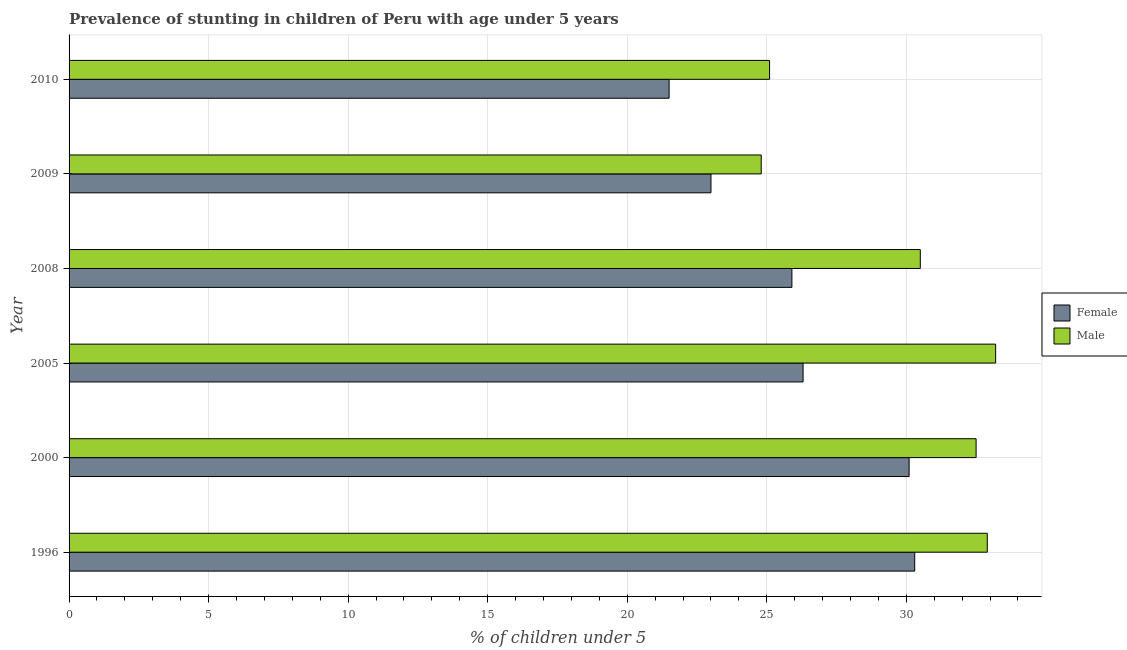How many groups of bars are there?
Keep it short and to the point. 6. Are the number of bars per tick equal to the number of legend labels?
Your response must be concise. Yes. What is the percentage of stunted female children in 2010?
Give a very brief answer. 21.5. Across all years, what is the maximum percentage of stunted female children?
Make the answer very short. 30.3. Across all years, what is the minimum percentage of stunted male children?
Offer a very short reply. 24.8. In which year was the percentage of stunted female children maximum?
Give a very brief answer. 1996. What is the total percentage of stunted female children in the graph?
Make the answer very short. 157.1. What is the difference between the percentage of stunted male children in 2000 and that in 2009?
Make the answer very short. 7.7. What is the difference between the percentage of stunted female children in 2000 and the percentage of stunted male children in 2010?
Your answer should be compact. 5. What is the average percentage of stunted male children per year?
Keep it short and to the point. 29.83. In the year 2005, what is the difference between the percentage of stunted female children and percentage of stunted male children?
Your answer should be very brief. -6.9. In how many years, is the percentage of stunted male children greater than 28 %?
Offer a very short reply. 4. Is the percentage of stunted male children in 2000 less than that in 2009?
Give a very brief answer. No. What is the difference between the highest and the lowest percentage of stunted male children?
Give a very brief answer. 8.4. In how many years, is the percentage of stunted female children greater than the average percentage of stunted female children taken over all years?
Ensure brevity in your answer.  3. Is the sum of the percentage of stunted female children in 1996 and 2009 greater than the maximum percentage of stunted male children across all years?
Make the answer very short. Yes. What does the 1st bar from the top in 2000 represents?
Ensure brevity in your answer.  Male. What does the 1st bar from the bottom in 2008 represents?
Give a very brief answer. Female. What is the difference between two consecutive major ticks on the X-axis?
Provide a short and direct response. 5. Does the graph contain any zero values?
Make the answer very short. No. Does the graph contain grids?
Your answer should be very brief. Yes. Where does the legend appear in the graph?
Give a very brief answer. Center right. What is the title of the graph?
Offer a very short reply. Prevalence of stunting in children of Peru with age under 5 years. Does "Foreign Liabilities" appear as one of the legend labels in the graph?
Your response must be concise. No. What is the label or title of the X-axis?
Your answer should be very brief.  % of children under 5. What is the label or title of the Y-axis?
Keep it short and to the point. Year. What is the  % of children under 5 in Female in 1996?
Provide a succinct answer. 30.3. What is the  % of children under 5 in Male in 1996?
Your answer should be very brief. 32.9. What is the  % of children under 5 of Female in 2000?
Give a very brief answer. 30.1. What is the  % of children under 5 of Male in 2000?
Provide a short and direct response. 32.5. What is the  % of children under 5 in Female in 2005?
Provide a succinct answer. 26.3. What is the  % of children under 5 in Male in 2005?
Your response must be concise. 33.2. What is the  % of children under 5 in Female in 2008?
Ensure brevity in your answer.  25.9. What is the  % of children under 5 of Male in 2008?
Provide a short and direct response. 30.5. What is the  % of children under 5 in Female in 2009?
Make the answer very short. 23. What is the  % of children under 5 of Male in 2009?
Give a very brief answer. 24.8. What is the  % of children under 5 of Male in 2010?
Your answer should be very brief. 25.1. Across all years, what is the maximum  % of children under 5 in Female?
Your answer should be compact. 30.3. Across all years, what is the maximum  % of children under 5 of Male?
Provide a short and direct response. 33.2. Across all years, what is the minimum  % of children under 5 of Male?
Offer a terse response. 24.8. What is the total  % of children under 5 in Female in the graph?
Give a very brief answer. 157.1. What is the total  % of children under 5 in Male in the graph?
Provide a succinct answer. 179. What is the difference between the  % of children under 5 in Male in 1996 and that in 2000?
Offer a very short reply. 0.4. What is the difference between the  % of children under 5 in Female in 1996 and that in 2009?
Make the answer very short. 7.3. What is the difference between the  % of children under 5 in Male in 2000 and that in 2009?
Your answer should be compact. 7.7. What is the difference between the  % of children under 5 of Male in 2000 and that in 2010?
Provide a short and direct response. 7.4. What is the difference between the  % of children under 5 in Female in 2005 and that in 2009?
Your answer should be very brief. 3.3. What is the difference between the  % of children under 5 in Male in 2005 and that in 2009?
Make the answer very short. 8.4. What is the difference between the  % of children under 5 of Female in 2005 and that in 2010?
Give a very brief answer. 4.8. What is the difference between the  % of children under 5 of Female in 1996 and the  % of children under 5 of Male in 2000?
Provide a succinct answer. -2.2. What is the difference between the  % of children under 5 in Female in 2000 and the  % of children under 5 in Male in 2005?
Your answer should be very brief. -3.1. What is the difference between the  % of children under 5 of Female in 2000 and the  % of children under 5 of Male in 2010?
Provide a succinct answer. 5. What is the difference between the  % of children under 5 in Female in 2005 and the  % of children under 5 in Male in 2008?
Provide a short and direct response. -4.2. What is the difference between the  % of children under 5 in Female in 2008 and the  % of children under 5 in Male in 2009?
Give a very brief answer. 1.1. What is the difference between the  % of children under 5 in Female in 2008 and the  % of children under 5 in Male in 2010?
Offer a terse response. 0.8. What is the average  % of children under 5 of Female per year?
Your answer should be very brief. 26.18. What is the average  % of children under 5 in Male per year?
Give a very brief answer. 29.83. In the year 1996, what is the difference between the  % of children under 5 in Female and  % of children under 5 in Male?
Make the answer very short. -2.6. In the year 2000, what is the difference between the  % of children under 5 of Female and  % of children under 5 of Male?
Give a very brief answer. -2.4. In the year 2005, what is the difference between the  % of children under 5 of Female and  % of children under 5 of Male?
Make the answer very short. -6.9. What is the ratio of the  % of children under 5 in Female in 1996 to that in 2000?
Your answer should be compact. 1.01. What is the ratio of the  % of children under 5 in Male in 1996 to that in 2000?
Your answer should be compact. 1.01. What is the ratio of the  % of children under 5 of Female in 1996 to that in 2005?
Your answer should be very brief. 1.15. What is the ratio of the  % of children under 5 of Male in 1996 to that in 2005?
Make the answer very short. 0.99. What is the ratio of the  % of children under 5 in Female in 1996 to that in 2008?
Offer a very short reply. 1.17. What is the ratio of the  % of children under 5 of Male in 1996 to that in 2008?
Ensure brevity in your answer.  1.08. What is the ratio of the  % of children under 5 in Female in 1996 to that in 2009?
Provide a short and direct response. 1.32. What is the ratio of the  % of children under 5 of Male in 1996 to that in 2009?
Provide a short and direct response. 1.33. What is the ratio of the  % of children under 5 in Female in 1996 to that in 2010?
Your answer should be very brief. 1.41. What is the ratio of the  % of children under 5 of Male in 1996 to that in 2010?
Your answer should be compact. 1.31. What is the ratio of the  % of children under 5 in Female in 2000 to that in 2005?
Make the answer very short. 1.14. What is the ratio of the  % of children under 5 of Male in 2000 to that in 2005?
Provide a short and direct response. 0.98. What is the ratio of the  % of children under 5 of Female in 2000 to that in 2008?
Give a very brief answer. 1.16. What is the ratio of the  % of children under 5 in Male in 2000 to that in 2008?
Provide a succinct answer. 1.07. What is the ratio of the  % of children under 5 of Female in 2000 to that in 2009?
Give a very brief answer. 1.31. What is the ratio of the  % of children under 5 of Male in 2000 to that in 2009?
Offer a terse response. 1.31. What is the ratio of the  % of children under 5 in Male in 2000 to that in 2010?
Ensure brevity in your answer.  1.29. What is the ratio of the  % of children under 5 in Female in 2005 to that in 2008?
Your answer should be compact. 1.02. What is the ratio of the  % of children under 5 in Male in 2005 to that in 2008?
Give a very brief answer. 1.09. What is the ratio of the  % of children under 5 of Female in 2005 to that in 2009?
Make the answer very short. 1.14. What is the ratio of the  % of children under 5 in Male in 2005 to that in 2009?
Keep it short and to the point. 1.34. What is the ratio of the  % of children under 5 of Female in 2005 to that in 2010?
Offer a terse response. 1.22. What is the ratio of the  % of children under 5 in Male in 2005 to that in 2010?
Offer a terse response. 1.32. What is the ratio of the  % of children under 5 in Female in 2008 to that in 2009?
Provide a succinct answer. 1.13. What is the ratio of the  % of children under 5 in Male in 2008 to that in 2009?
Keep it short and to the point. 1.23. What is the ratio of the  % of children under 5 in Female in 2008 to that in 2010?
Offer a very short reply. 1.2. What is the ratio of the  % of children under 5 in Male in 2008 to that in 2010?
Give a very brief answer. 1.22. What is the ratio of the  % of children under 5 in Female in 2009 to that in 2010?
Your answer should be very brief. 1.07. What is the difference between the highest and the lowest  % of children under 5 in Male?
Ensure brevity in your answer.  8.4. 